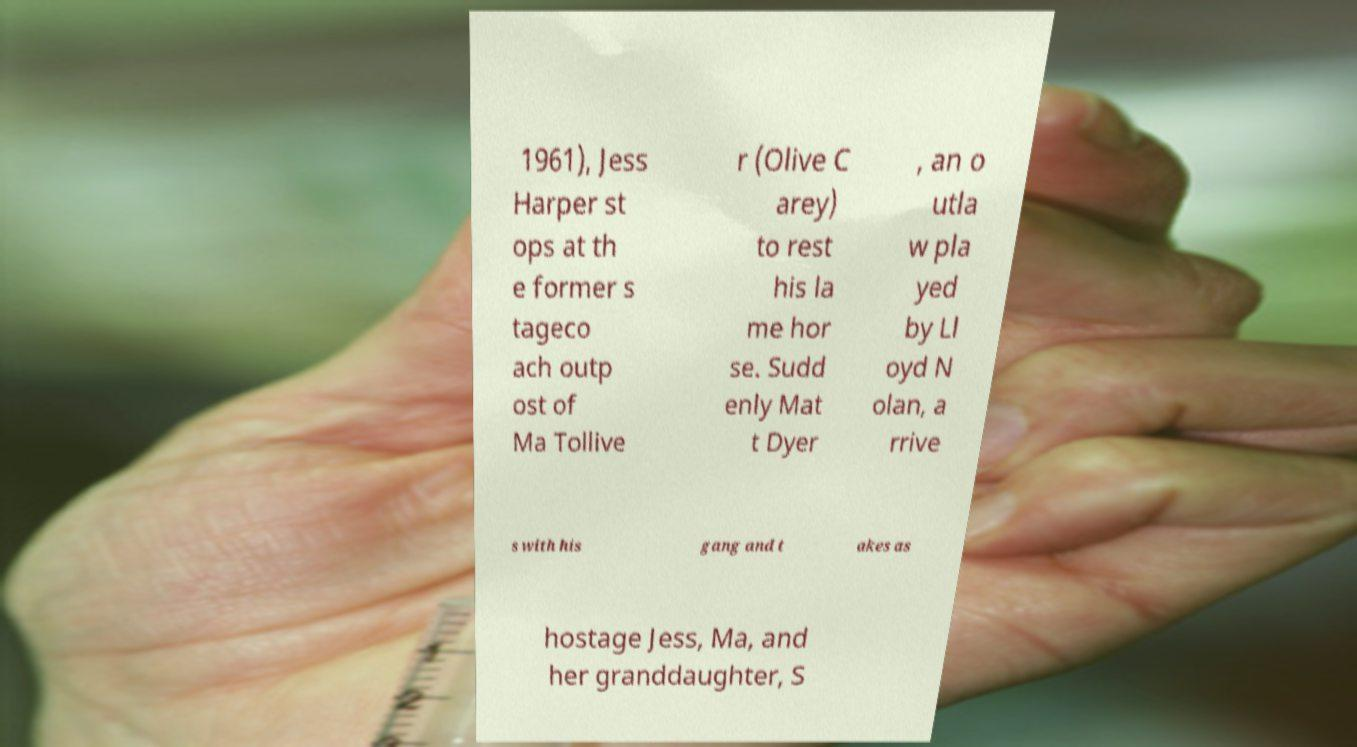Please identify and transcribe the text found in this image. 1961), Jess Harper st ops at th e former s tageco ach outp ost of Ma Tollive r (Olive C arey) to rest his la me hor se. Sudd enly Mat t Dyer , an o utla w pla yed by Ll oyd N olan, a rrive s with his gang and t akes as hostage Jess, Ma, and her granddaughter, S 